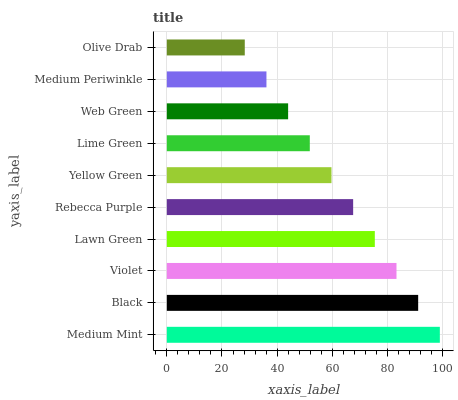Is Olive Drab the minimum?
Answer yes or no. Yes. Is Medium Mint the maximum?
Answer yes or no. Yes. Is Black the minimum?
Answer yes or no. No. Is Black the maximum?
Answer yes or no. No. Is Medium Mint greater than Black?
Answer yes or no. Yes. Is Black less than Medium Mint?
Answer yes or no. Yes. Is Black greater than Medium Mint?
Answer yes or no. No. Is Medium Mint less than Black?
Answer yes or no. No. Is Rebecca Purple the high median?
Answer yes or no. Yes. Is Yellow Green the low median?
Answer yes or no. Yes. Is Medium Periwinkle the high median?
Answer yes or no. No. Is Lawn Green the low median?
Answer yes or no. No. 